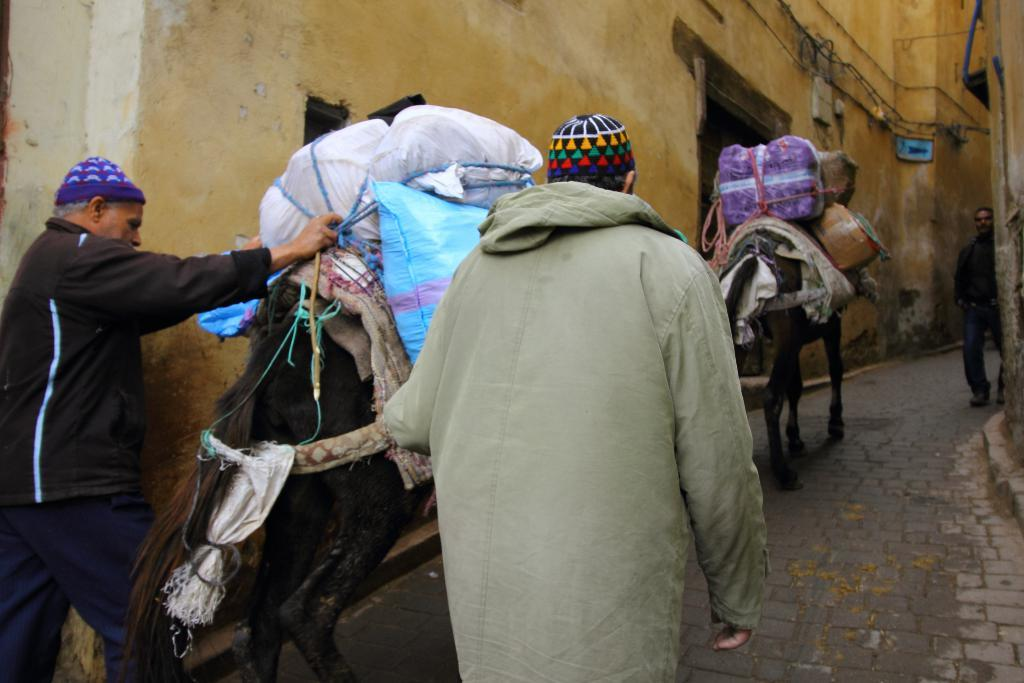What animals are present in the image? There are two camels in the image. What is on the camels? The camels have weights on them. What are the people in the image doing? There are three men walking in the image. What is the value of the camels in the image? The value of the camels cannot be determined from the image alone, as it does not provide information about their worth. 